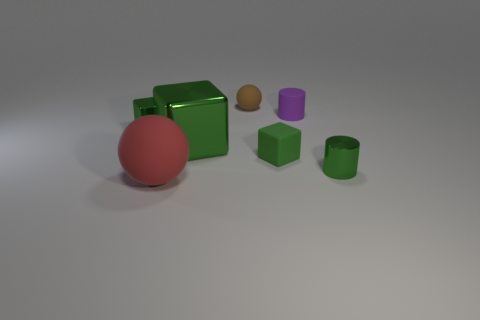Can you describe the shapes and colors of the objects in the image? Certainly. The image features a collection of five objects in total. There's a large green cube, a small green cube, and a green cylinder, all of which have a matte finish. Additionally, there's a glossy red sphere and a matte brownish sphere, which has a smaller size compared to the others. Lastly, there's a smaller, glossy purple cylinder. 